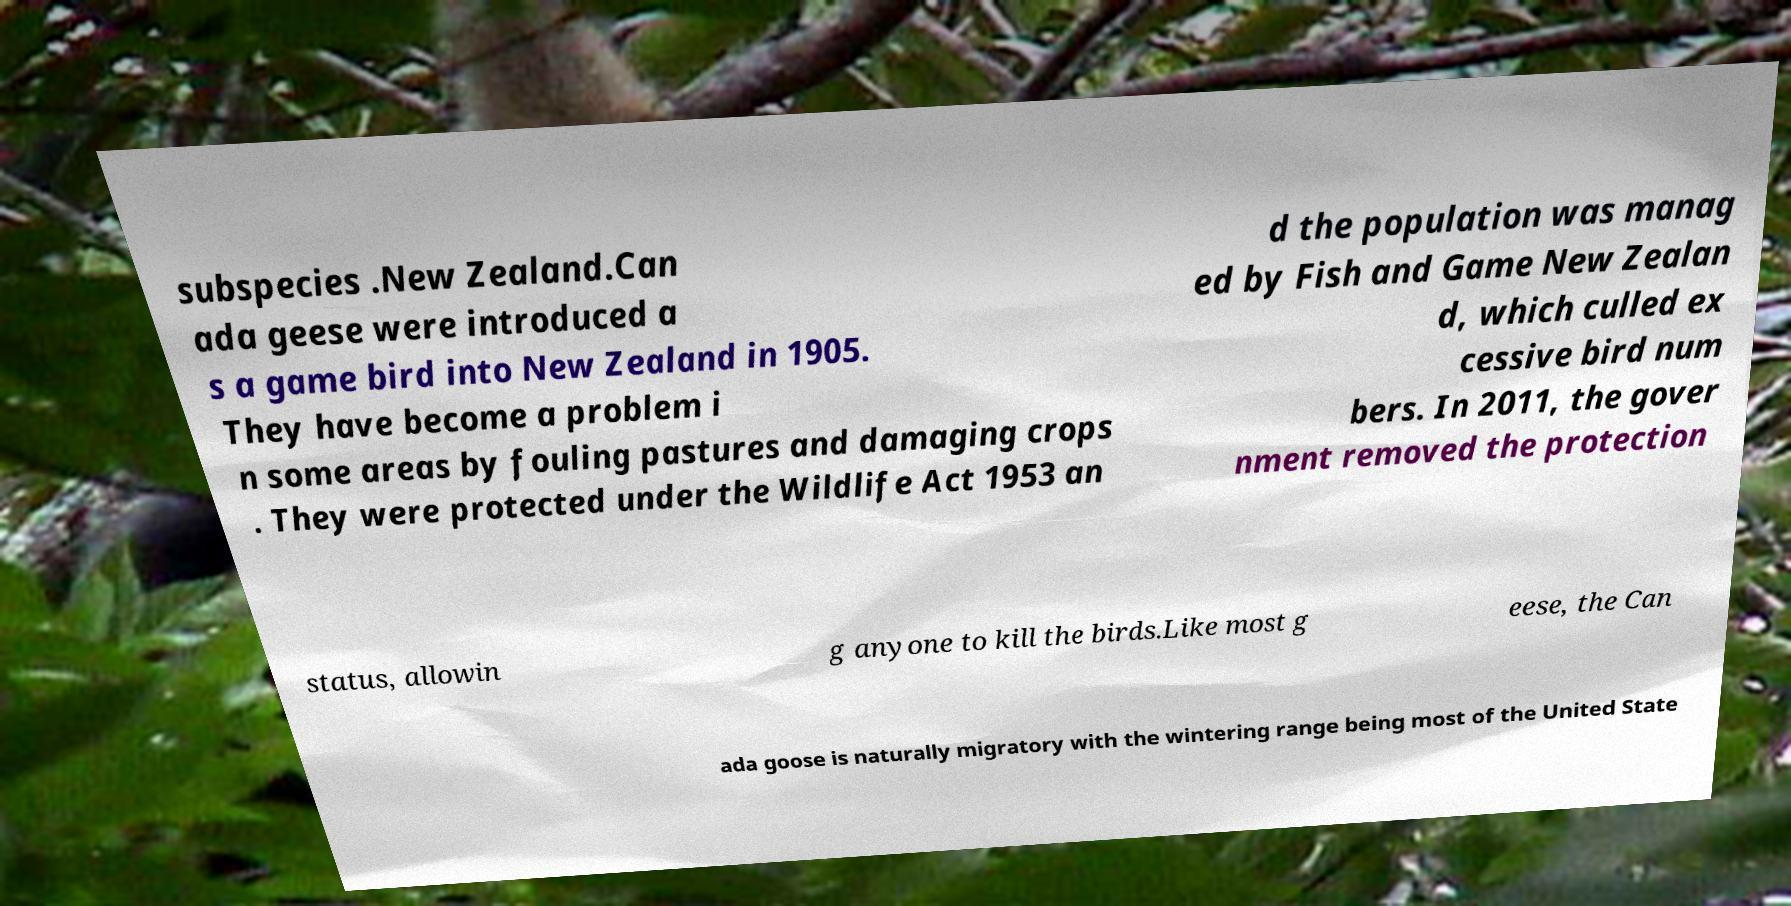For documentation purposes, I need the text within this image transcribed. Could you provide that? subspecies .New Zealand.Can ada geese were introduced a s a game bird into New Zealand in 1905. They have become a problem i n some areas by fouling pastures and damaging crops . They were protected under the Wildlife Act 1953 an d the population was manag ed by Fish and Game New Zealan d, which culled ex cessive bird num bers. In 2011, the gover nment removed the protection status, allowin g anyone to kill the birds.Like most g eese, the Can ada goose is naturally migratory with the wintering range being most of the United State 